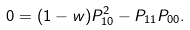Convert formula to latex. <formula><loc_0><loc_0><loc_500><loc_500>0 = ( 1 - w ) P _ { 1 0 } ^ { 2 } - P _ { 1 1 } P _ { 0 0 } .</formula> 